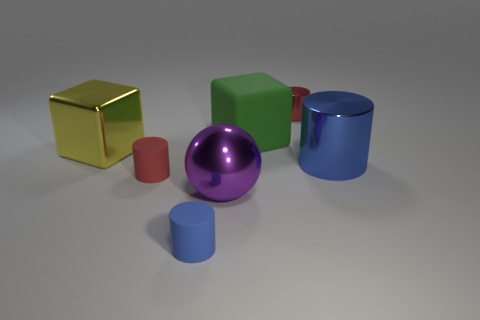Are there any blue shiny cylinders that are in front of the big purple ball that is to the right of the yellow cube?
Provide a succinct answer. No. There is a blue metal thing; is it the same shape as the rubber object behind the yellow thing?
Provide a short and direct response. No. What is the size of the rubber object that is both behind the large purple thing and to the left of the purple thing?
Keep it short and to the point. Small. Are there any small brown blocks that have the same material as the tiny blue thing?
Your response must be concise. No. The rubber thing that is the same color as the large cylinder is what size?
Your answer should be compact. Small. There is a red cylinder that is behind the blue cylinder that is to the right of the tiny metallic cylinder; what is its material?
Your answer should be very brief. Metal. How many other objects have the same color as the tiny metallic object?
Provide a short and direct response. 1. There is a green cube that is made of the same material as the tiny blue cylinder; what size is it?
Offer a very short reply. Large. What is the shape of the big purple thing that is in front of the large matte block?
Offer a very short reply. Sphere. The red rubber thing that is the same shape as the blue metal object is what size?
Give a very brief answer. Small. 